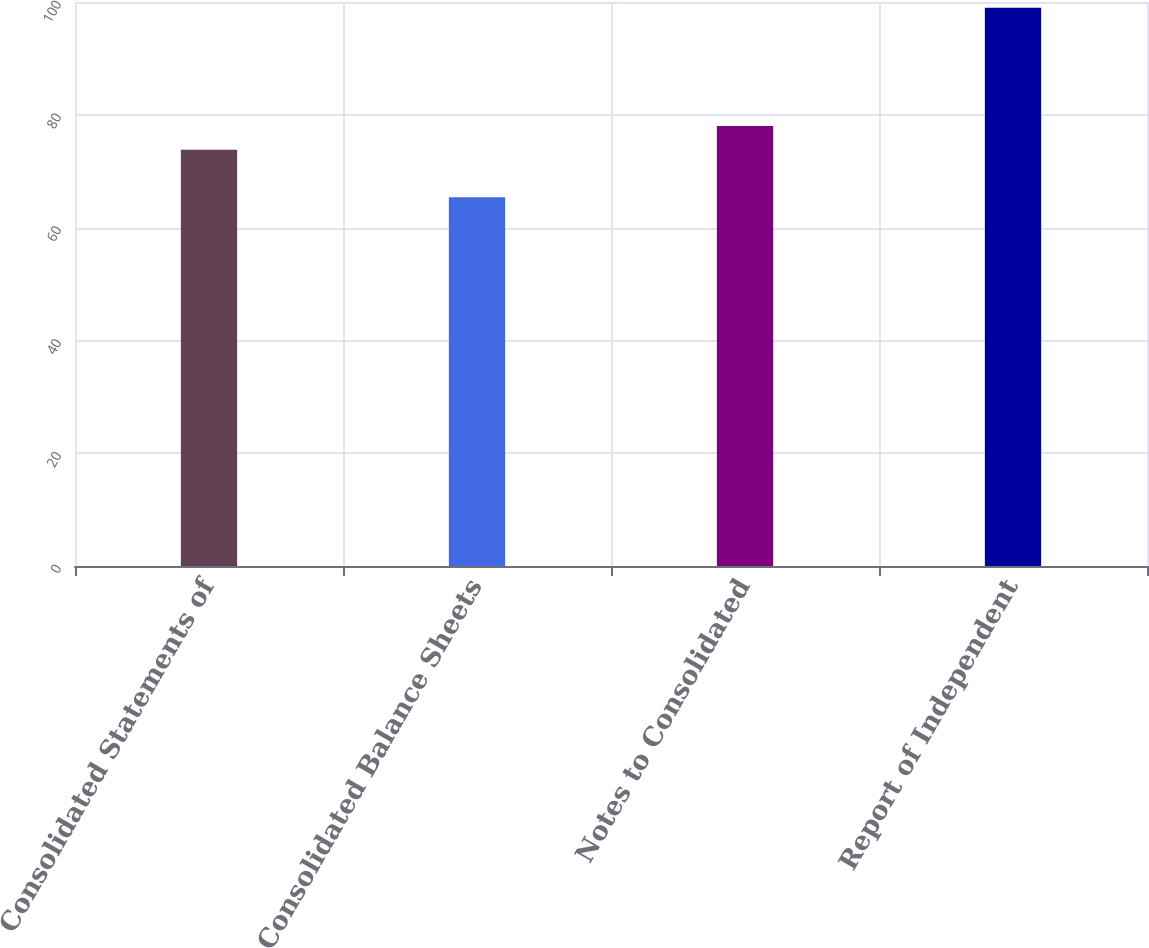<chart> <loc_0><loc_0><loc_500><loc_500><bar_chart><fcel>Consolidated Statements of<fcel>Consolidated Balance Sheets<fcel>Notes to Consolidated<fcel>Report of Independent<nl><fcel>73.8<fcel>65.4<fcel>78<fcel>99<nl></chart> 